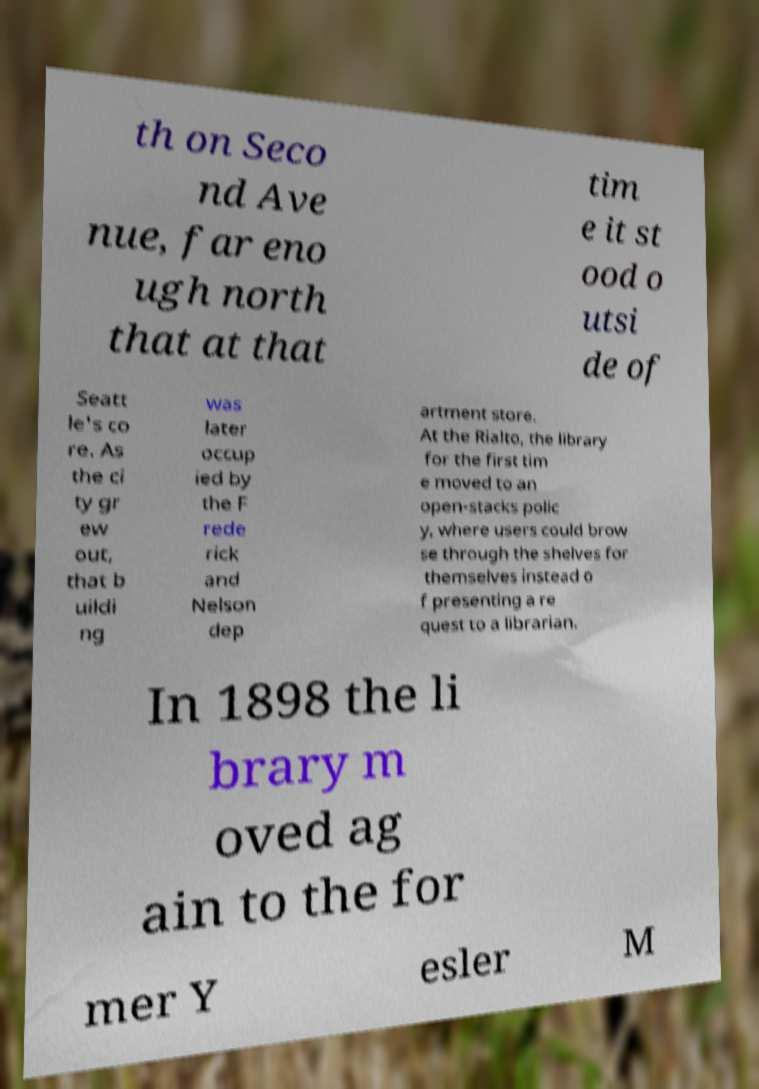For documentation purposes, I need the text within this image transcribed. Could you provide that? th on Seco nd Ave nue, far eno ugh north that at that tim e it st ood o utsi de of Seatt le's co re. As the ci ty gr ew out, that b uildi ng was later occup ied by the F rede rick and Nelson dep artment store. At the Rialto, the library for the first tim e moved to an open-stacks polic y, where users could brow se through the shelves for themselves instead o f presenting a re quest to a librarian. In 1898 the li brary m oved ag ain to the for mer Y esler M 